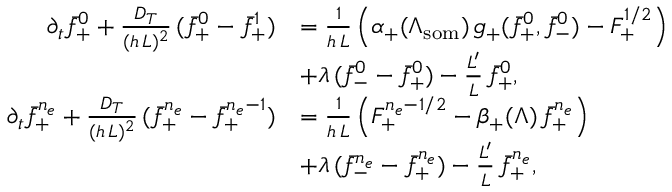<formula> <loc_0><loc_0><loc_500><loc_500>\begin{array} { r l } { \partial _ { t } \bar { f } _ { + } ^ { 0 } + \frac { D _ { T } } { ( h \, L ) ^ { 2 } } \, ( \bar { f } _ { + } ^ { 0 } - \bar { f } _ { + } ^ { 1 } ) } & { = \frac { 1 } h \, L } \left ( \alpha _ { + } ( \Lambda _ { s o m } ) \, g _ { + } ( \bar { f } _ { + } ^ { 0 } , \bar { f } _ { - } ^ { 0 } ) - F _ { + } ^ { 1 / 2 } \right ) } \\ & { + \lambda \, ( \bar { f } _ { - } ^ { 0 } - \bar { f } _ { + } ^ { 0 } ) - \frac { L ^ { \prime } } { L } \, \bar { f } _ { + } ^ { 0 } , } \\ { \partial _ { t } \bar { f } _ { + } ^ { n _ { e } } + \frac { D _ { T } } { ( h \, L ) ^ { 2 } } \, ( \bar { f } _ { + } ^ { n _ { e } } - \bar { f } _ { + } ^ { n _ { e } - 1 } ) } & { = \frac { 1 } h \, L } \left ( F _ { + } ^ { n _ { e } - 1 / 2 } - \beta _ { + } ( \Lambda ) \, \bar { f } _ { + } ^ { n _ { e } } \right ) } \\ & { + \lambda \, ( \bar { f } _ { - } ^ { n _ { e } } - \bar { f } _ { + } ^ { n _ { e } } ) - \frac { L ^ { \prime } } { L } \, \bar { f } _ { + } ^ { n _ { e } } , } \end{array}</formula> 